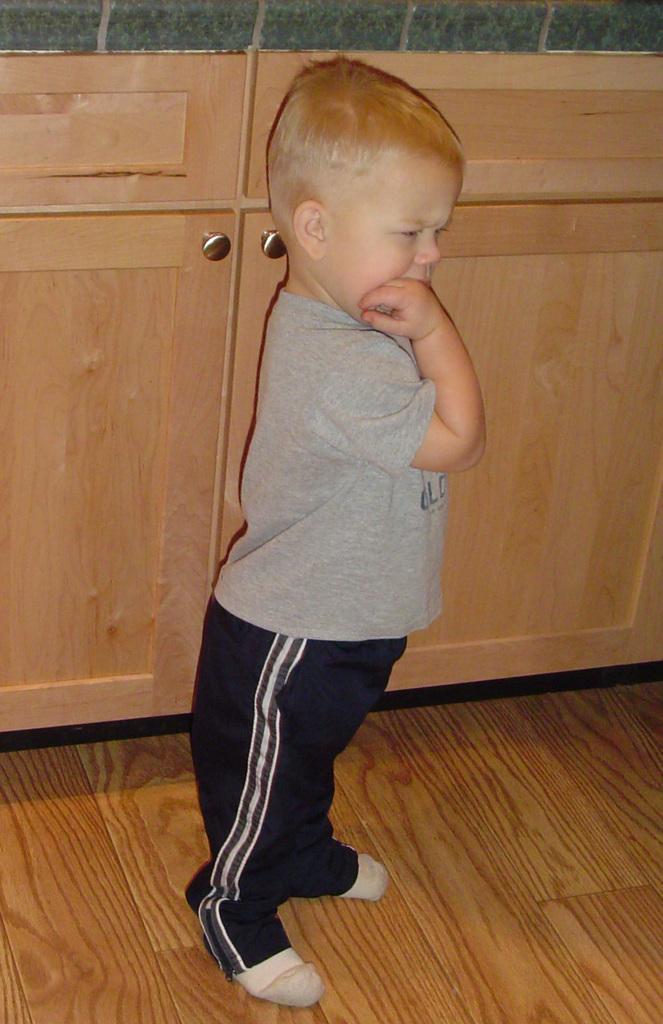Can you describe this image briefly? In this image we can see a child wearing T-shirt, pant and socks is standing on the wooden flooring. In the background, we can see the wooden cupboards. 